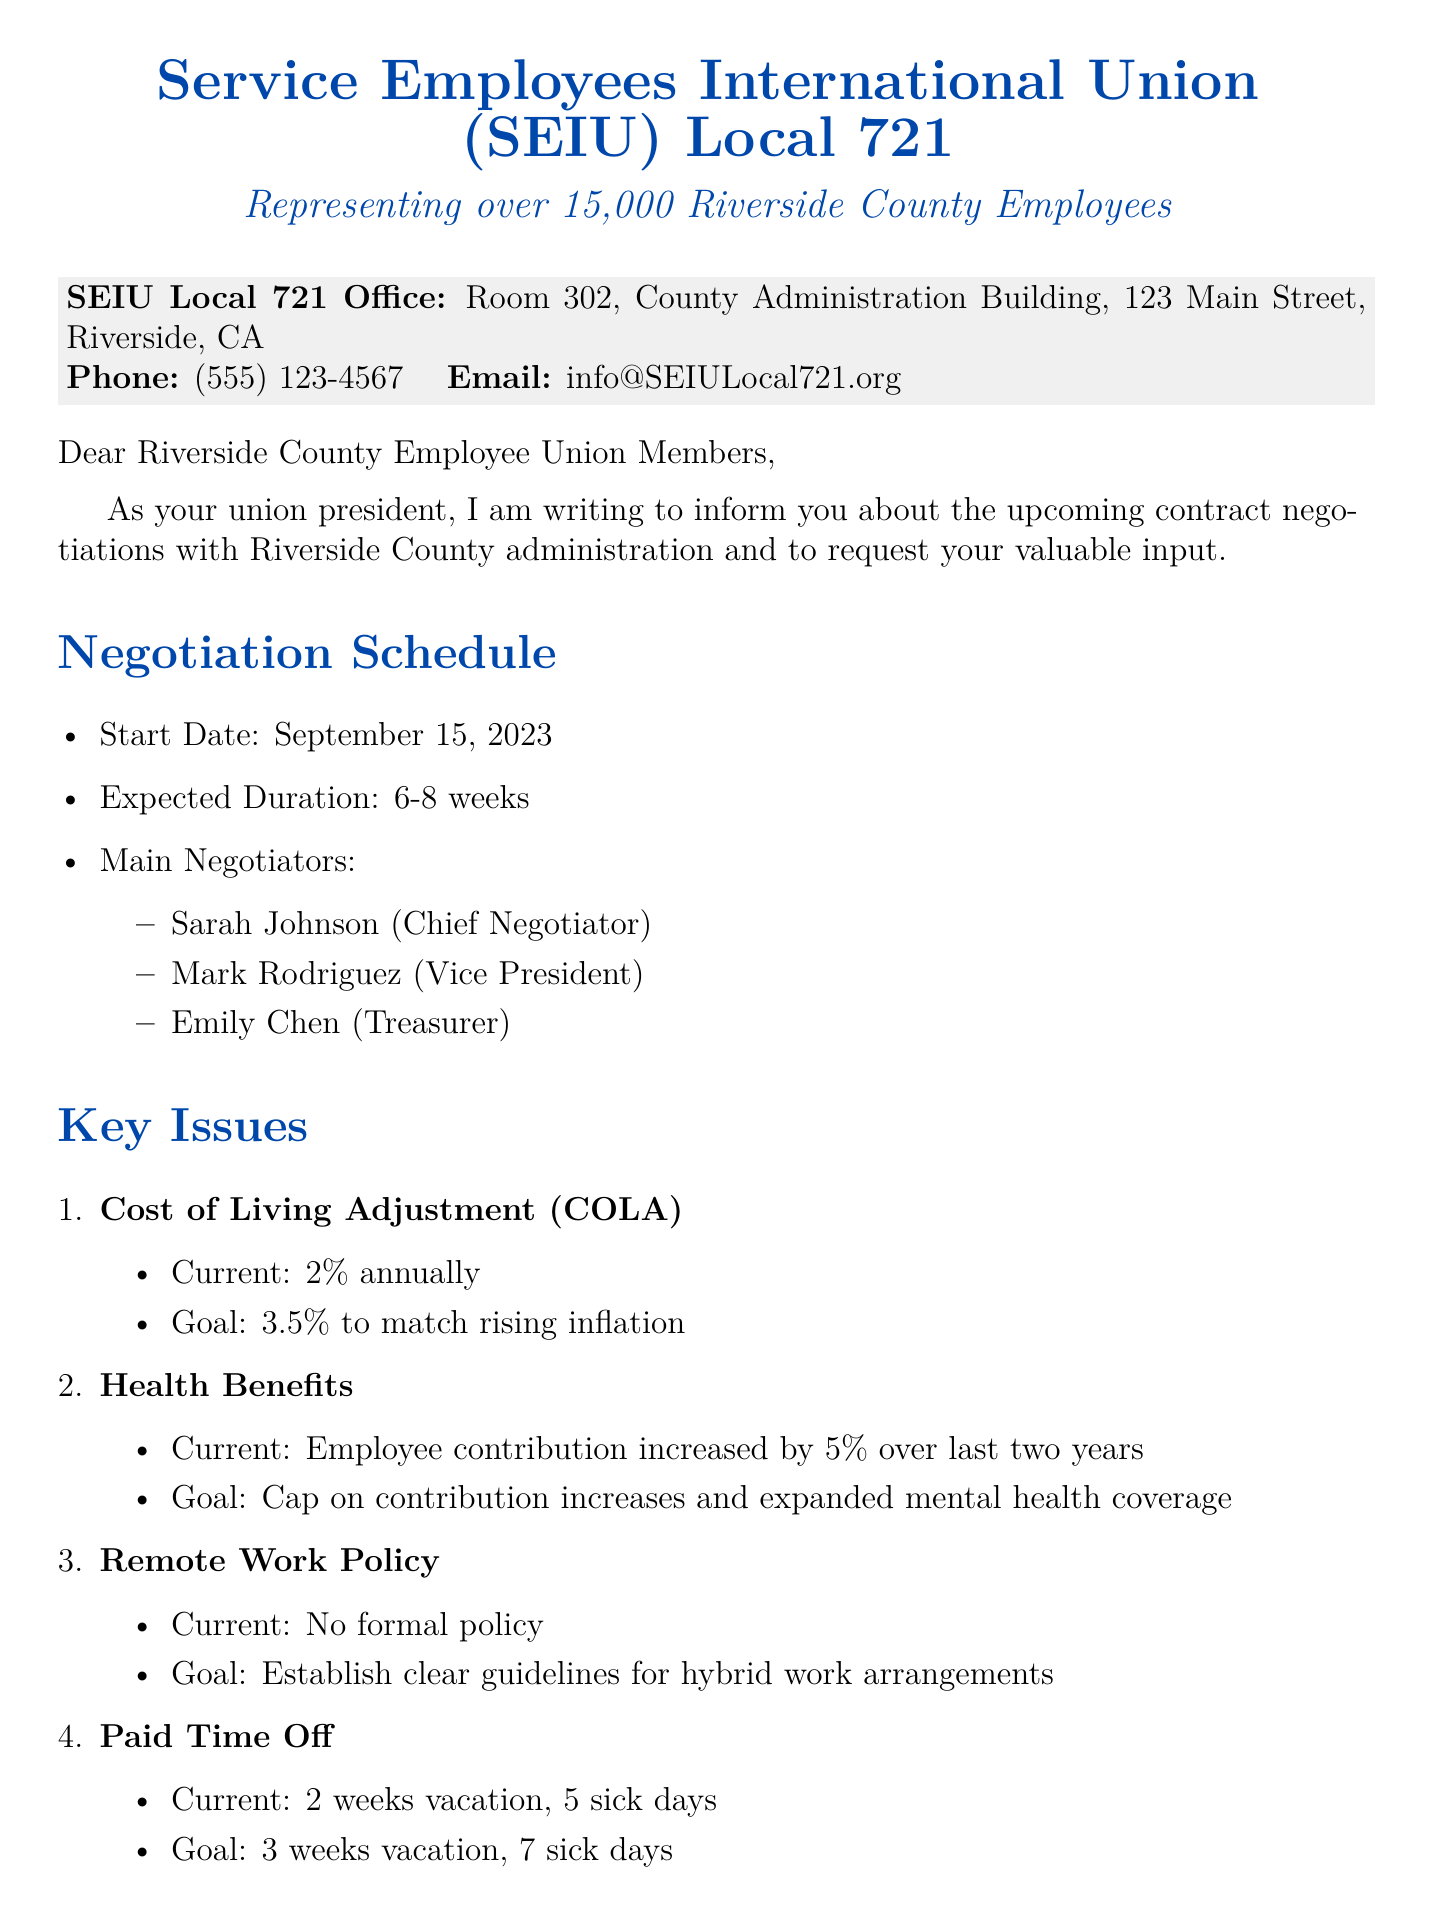What is the start date of the negotiations? The start date is specified in the negotiation schedule section of the document.
Answer: September 15, 2023 Who is the Chief Negotiator? The Chief Negotiator's name is listed under the negotiation schedule.
Answer: Sarah Johnson What is the goal for the Cost of Living Adjustment (COLA)? The document describes the union's goal for COLA in the key issues section.
Answer: 3.5% What is the deadline for member feedback? The deadline for feedback is mentioned in the member feedback request section.
Answer: August 31, 2023 How many sick days are currently offered? The current number of sick days is indicated in the key issues section.
Answer: 5 sick days What event occurs on August 25, 2023? The event name and details are found in the upcoming meetings section of the document.
Answer: Pre-negotiation Information Session What is the location for the Negotiation Update Meeting? The location for the meeting is specified in the upcoming meetings section.
Answer: Virtual meeting via Zoom What is the email for submitting feedback? The document includes the submission methods and relevant email addresses.
Answer: feedback@SEIULocal721.org How many members does the union represent? The membership size is provided in the union details at the beginning of the document.
Answer: over 15,000 members 